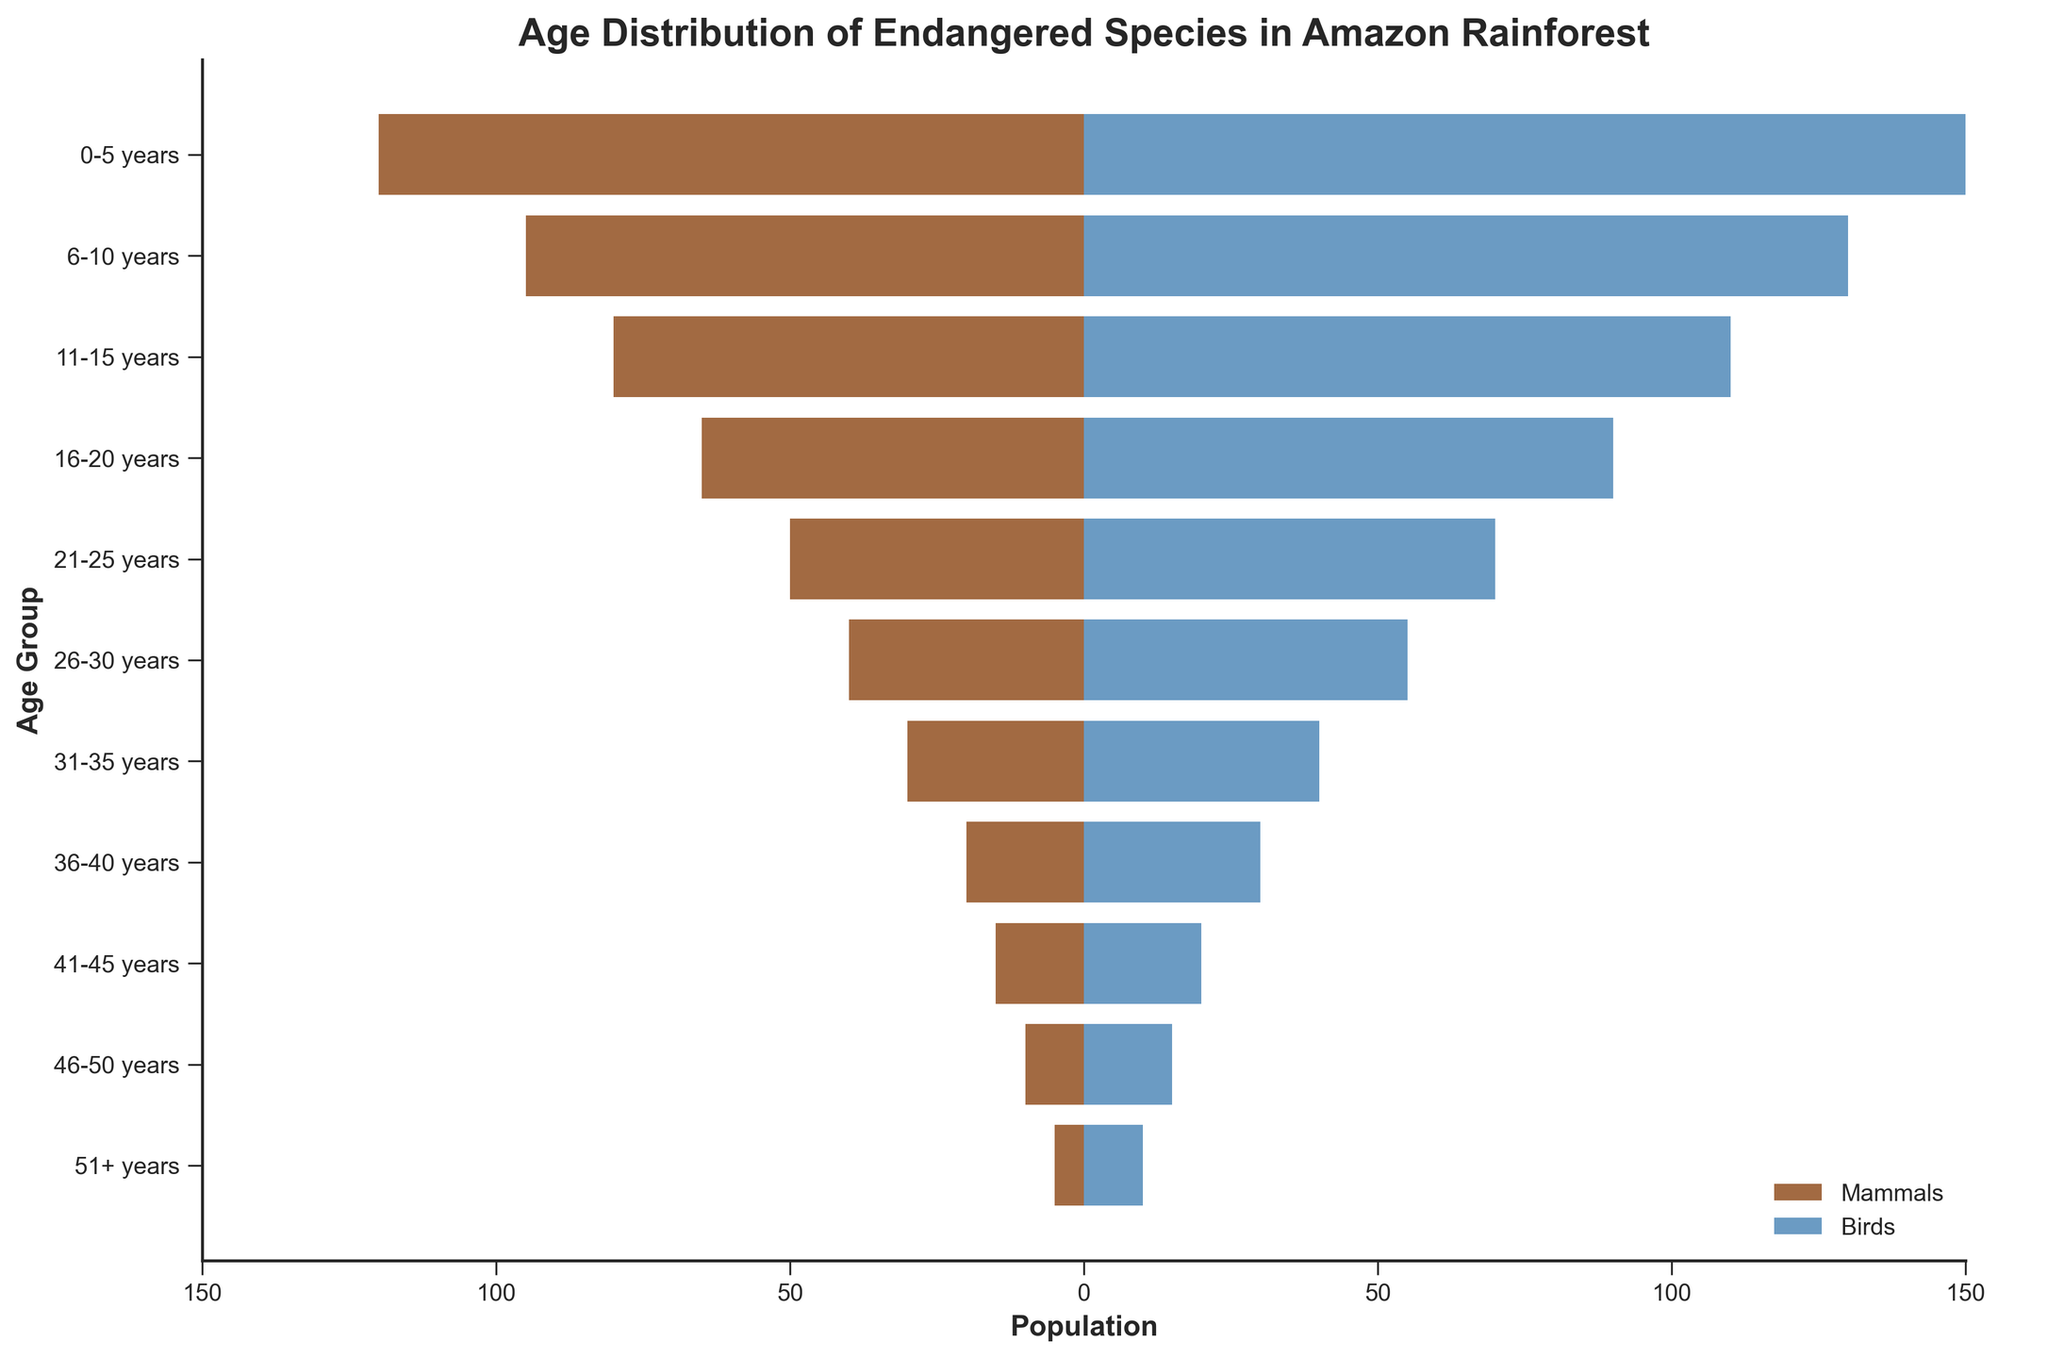What is the title of the plot? The title is the text at the top of the figure that indicates what the plot is about. Here, it reads "Age Distribution of Endangered Species in Amazon Rainforest."
Answer: Age Distribution of Endangered Species in Amazon Rainforest What is the age group with the highest population of birds? To find the age group with the highest population of birds, look for the longest blue bar on the right side of the plot. The longest blue bar corresponds to the 0-5 years age group.
Answer: 0-5 years How many age groups are displayed in the plot? Each horizontal bar represents an age group. By counting these horizontal bars, one can determine the number of age groups in the plot. There are 11 horizontal bars.
Answer: 11 Which age group has the smallest population of mammals? To find the age group with the smallest population of mammals, look for the shortest brown bar on the left side of the plot. The shortest brown bar corresponds to the 51+ years age group.
Answer: 51+ years What is the total population of mammals aged 16-20 years and birds aged 16-20 years combined? Add the absolute value of the mammal population (65) to the bird population (90) for the 16-20 years age group: 65 + 90 = 155.
Answer: 155 Are there more mammals or birds in the 26-30 years age group? Compare the lengths of the brown and blue bars for the 26-30 years age group. The brown bar represents 40 mammals and the blue bar represents 55 birds. Since 55 is greater than 40, there are more birds.
Answer: Birds Which age group has an equal population of mammals and birds? In the plot, no brown bar is equal in length to any blue bar across the same age group. Therefore, there is no age group where the populations of mammals and birds are equal.
Answer: None How does the population of mammals in the 11-15 years age group compare to the population of birds in the same age group? The population of mammals is represented by the brown bar (-80) and the population of birds by the blue bar (110) for the 11-15 years age group. Since 110 (birds) is greater than 80 (mammals), birds have a higher population.
Answer: Birds have a higher population What is the general trend of the population as the age group increases? Observe the overall lengths of the bars as you move from younger to older age groups. Both the brown and blue bars decrease in length, indicating a trend of decreasing population as the age group increases.
Answer: Decreasing population How much greater is the population of birds aged 6-10 years compared to mammals aged 6-10 years? Calculate the absolute difference between the populations of birds (130) and mammals (95) for the 6-10 years age group: 130 - 95 = 35.
Answer: 35 